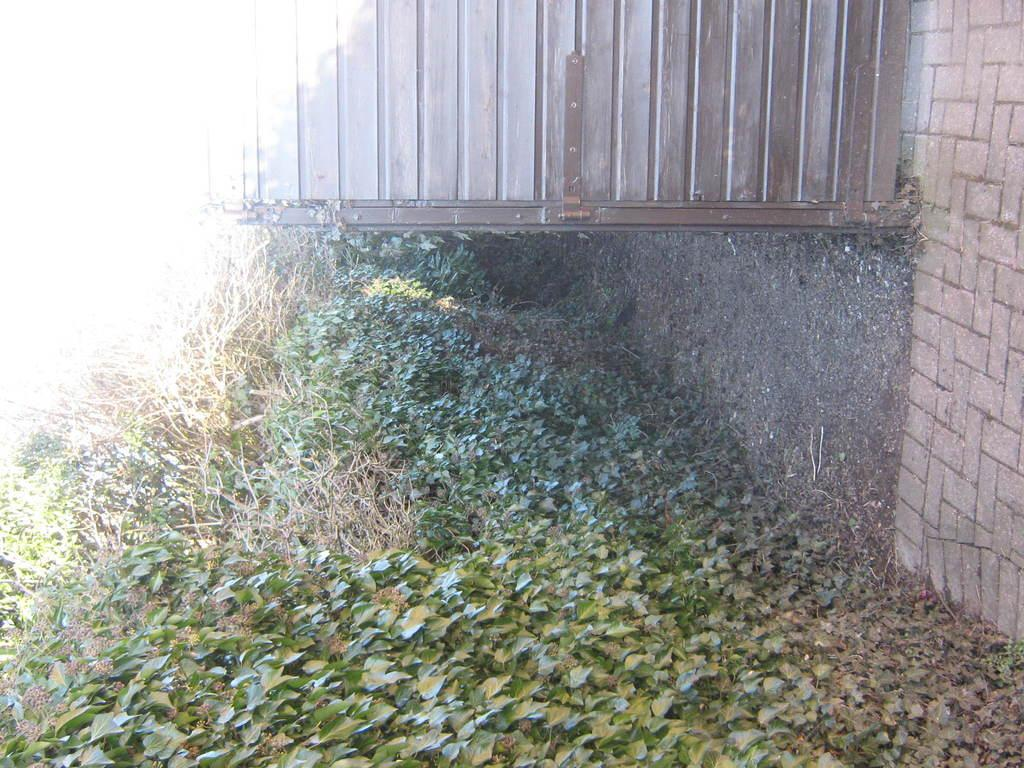What type of structure can be seen in the image? There is a wall in the image. What is visible beside the wall? The ground is visible beside the wall. What type of vegetation is present on the ground? There are plants and grass on the ground. What additional objects can be seen on the ground? Dried leaves are on the ground. What is at the top of the wall? There is a metal railing at the top of the wall. What historical process is depicted in the image? There is no historical process depicted in the image; it shows a wall, ground, plants, grass, dried leaves, and a metal railing. Can you see any worms crawling on the plants in the image? There are no worms visible in the image; it only shows plants, grass, dried leaves, and a metal railing. 